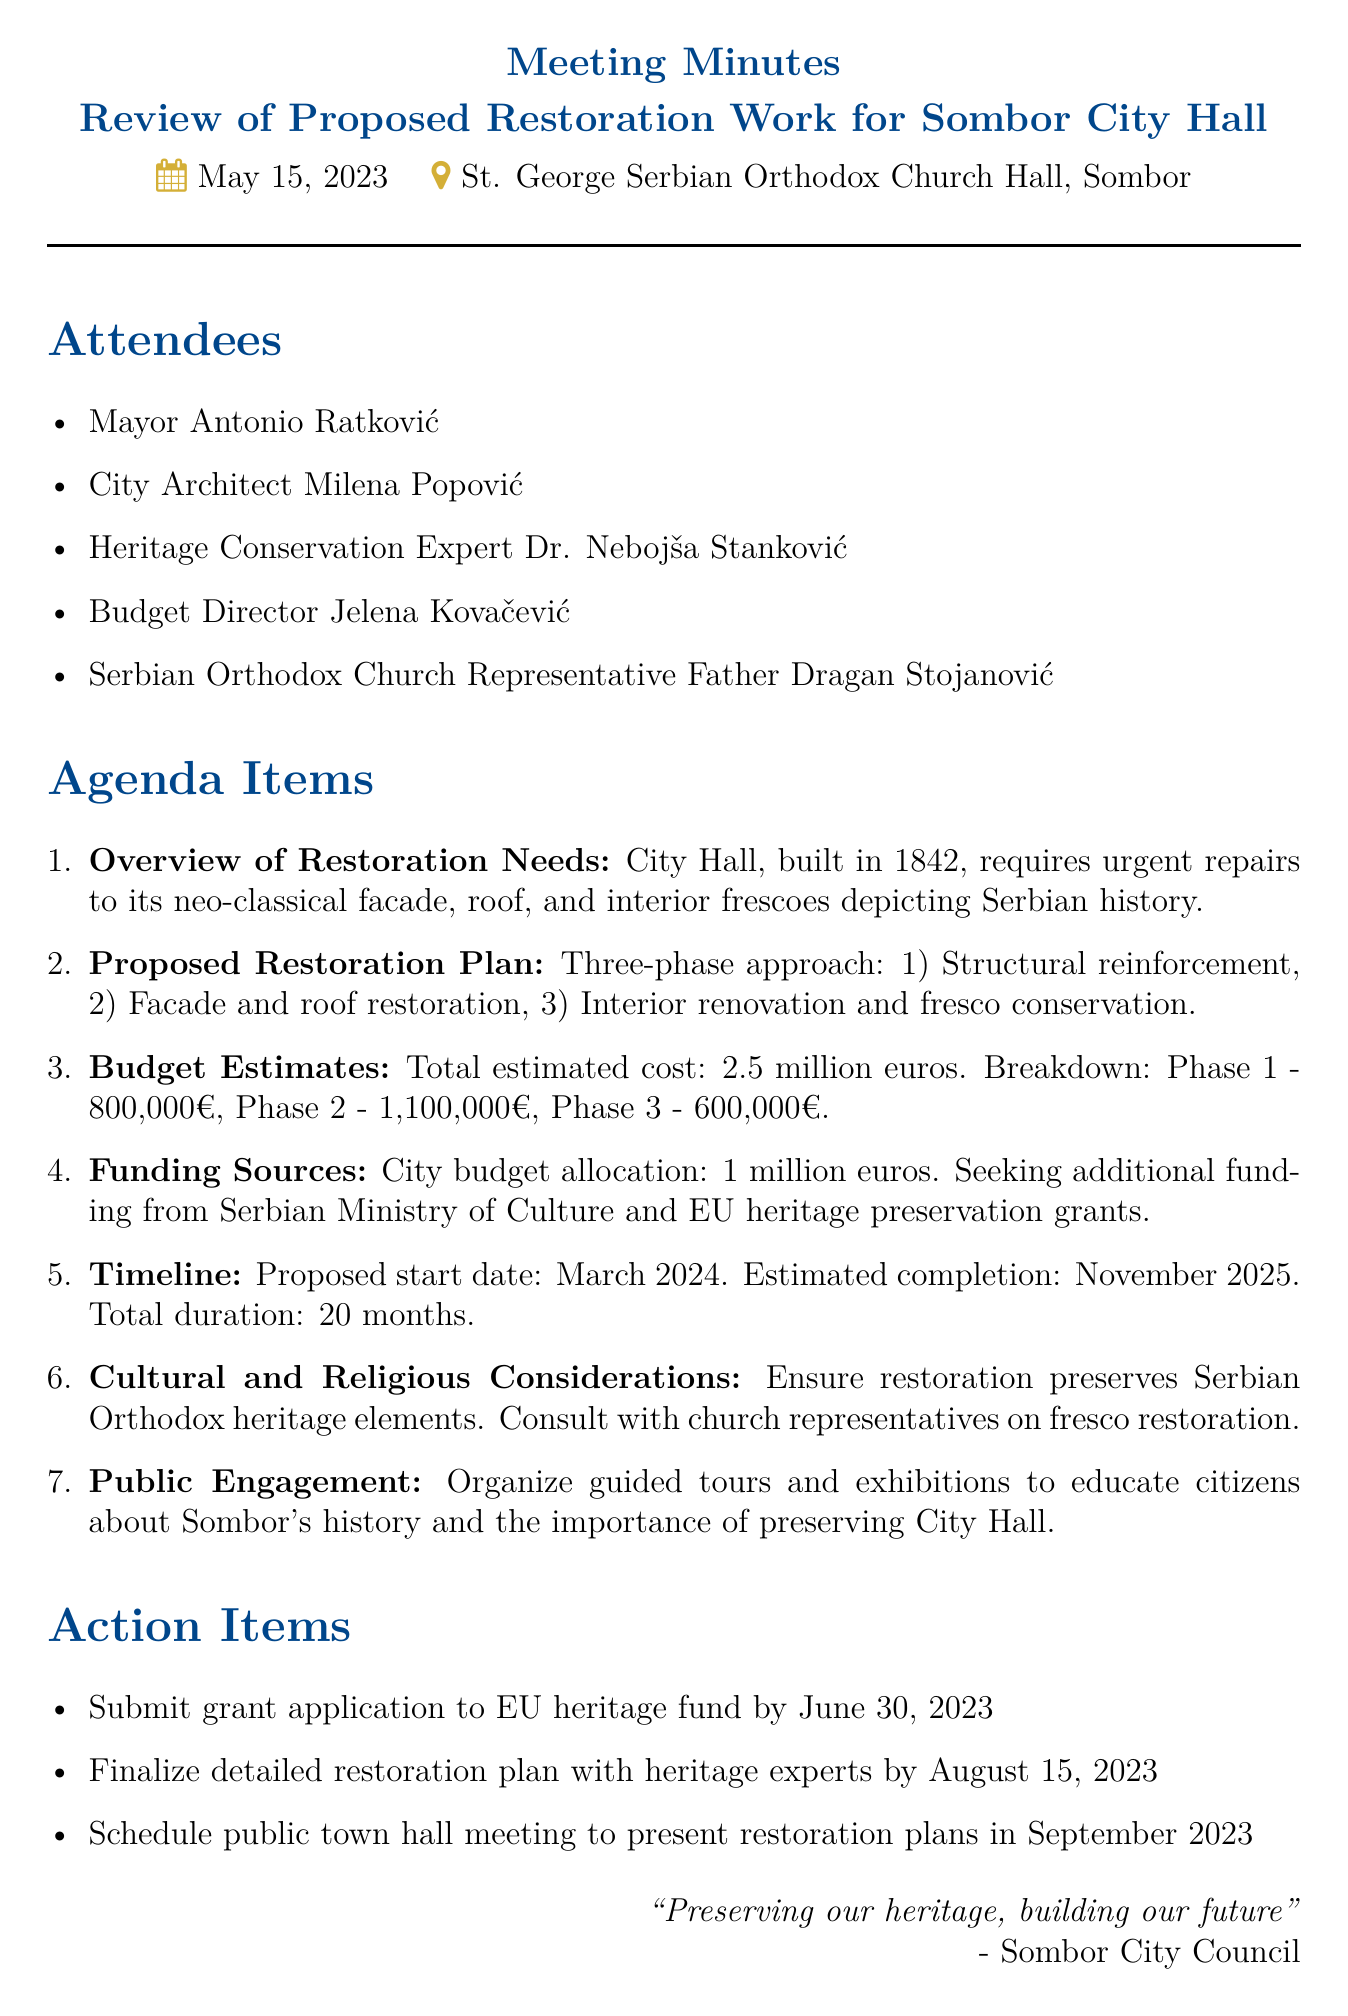What is the date of the meeting? The date of the meeting is explicitly stated at the beginning of the document.
Answer: May 15, 2023 Who is the City Architect mentioned in the attendees? The document lists the names of attendees, including their titles.
Answer: Milena Popović What is the total estimated cost for the restoration? The total estimated cost is explicitly provided in the budget estimates section.
Answer: 2.5 million euros What is the proposed start date of the restoration work? The timeline for the restoration work is stated clearly in the timeline section.
Answer: March 2024 How many phases are in the proposed restoration plan? The proposed restoration plan outlines the number of phases involved.
Answer: Three What action item is due by June 30, 2023? The action items list specific deadlines for tasks to be completed.
Answer: Submit grant application to EU heritage fund What is one cultural consideration mentioned in the meeting? The document specifies important cultural aspects to consider during the restoration.
Answer: Preserve Serbian Orthodox heritage elements When is the estimated completion date for the restoration? The timeline section provides the expected completion date for the work.
Answer: November 2025 